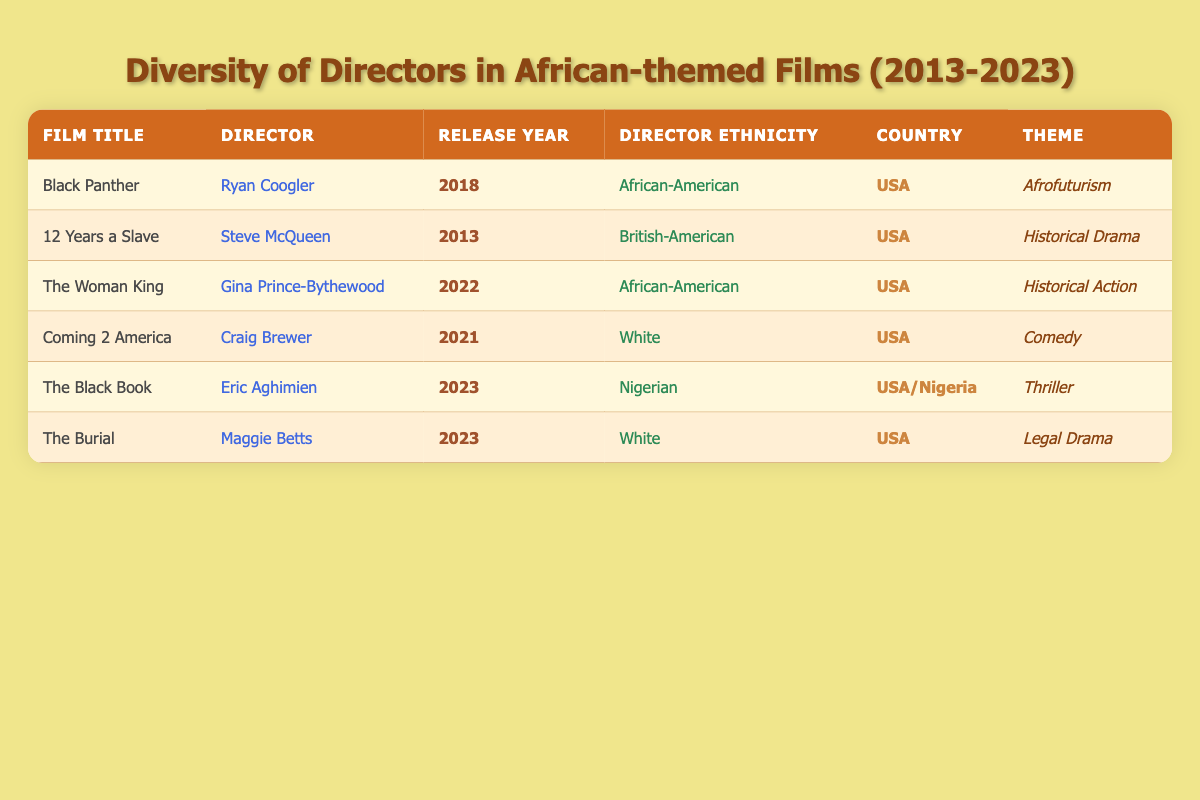What is the title of the film directed by Ryan Coogler? The table shows that Ryan Coogler directed the film titled "Black Panther."
Answer: Black Panther How many films are listed in the table? By counting the rows under the film title column in the table, there are a total of 6 films listed.
Answer: 6 Which director has Nigerian ethnicity? Referring to the Director Ethnicity column, Eric Aghimien is the only director with Nigerian ethnicity, associated with the film "The Black Book."
Answer: Eric Aghimien What is the release year of "The Woman King"? Looking at the row for "The Woman King," it is noted that the release year is 2022.
Answer: 2022 How many films have directors of African descent? The table lists two directors of African descent: Ryan Coogler and Gina Prince-Bythewood, who directed "Black Panther" and "The Woman King," respectively.
Answer: 2 Is "12 Years a Slave" an African-themed film directed by a person of African descent? While "12 Years a Slave" is indeed an African-themed film, it is directed by Steve McQueen who is noted as British-American, thus the answer is no.
Answer: No What percentage of the films listed are directed by individuals who are not white? Out of the 6 films, 2 are directed by individuals of African descent (Ryan Coogler and Gina Prince-Bythewood), which gives us (2/6)*100 = 33.33%.
Answer: 33.33% Which film has the theme "Thriller"? The table reveals that "The Black Book" is classified under the theme "Thriller."
Answer: The Black Book What is the total number of films listed with a release year of 2023? The table indicates that there are two films released in 2023: "The Black Book" and "The Burial."
Answer: 2 Identify the countries of the films directed by female directors. Referring to the table, the films directed by female directors are "The Woman King" (USA) and "The Burial" (USA).
Answer: USA 